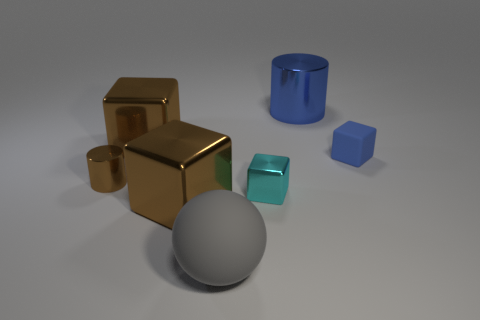Subtract all tiny metal cubes. How many cubes are left? 3 Add 1 tiny purple matte cubes. How many objects exist? 8 Subtract all gray cylinders. How many brown cubes are left? 2 Subtract 1 blocks. How many blocks are left? 3 Subtract all spheres. How many objects are left? 6 Subtract all blue cylinders. How many cylinders are left? 1 Add 3 blue rubber things. How many blue rubber things are left? 4 Add 2 shiny cubes. How many shiny cubes exist? 5 Subtract 2 brown cubes. How many objects are left? 5 Subtract all purple cylinders. Subtract all cyan spheres. How many cylinders are left? 2 